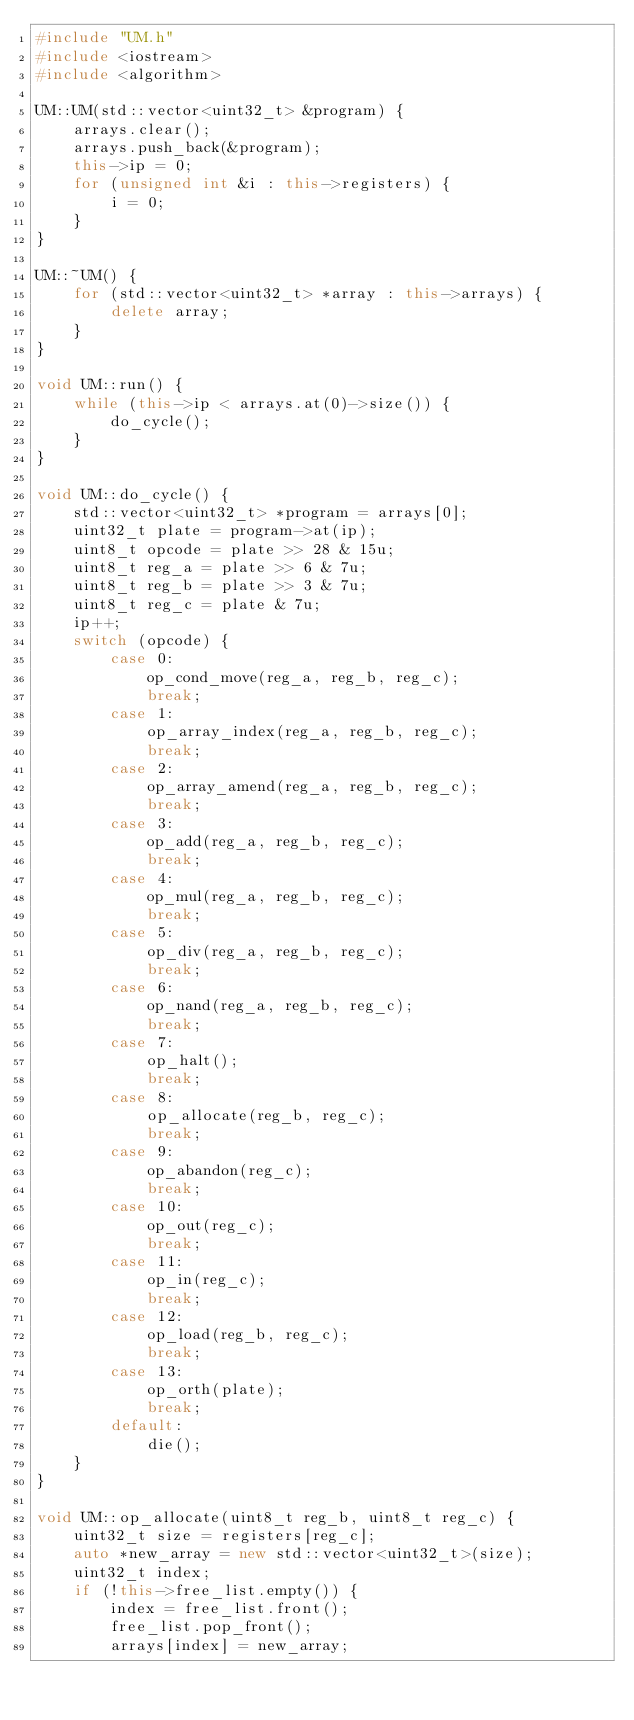Convert code to text. <code><loc_0><loc_0><loc_500><loc_500><_C++_>#include "UM.h"
#include <iostream>
#include <algorithm>

UM::UM(std::vector<uint32_t> &program) {
    arrays.clear();
    arrays.push_back(&program);
    this->ip = 0;
    for (unsigned int &i : this->registers) {
        i = 0;
    }
}

UM::~UM() {
    for (std::vector<uint32_t> *array : this->arrays) {
        delete array;
    }
}

void UM::run() {
    while (this->ip < arrays.at(0)->size()) {
        do_cycle();
    }
}

void UM::do_cycle() {
    std::vector<uint32_t> *program = arrays[0];
    uint32_t plate = program->at(ip);
    uint8_t opcode = plate >> 28 & 15u;
    uint8_t reg_a = plate >> 6 & 7u;
    uint8_t reg_b = plate >> 3 & 7u;
    uint8_t reg_c = plate & 7u;
    ip++;
    switch (opcode) {
        case 0:
            op_cond_move(reg_a, reg_b, reg_c);
            break;
        case 1:
            op_array_index(reg_a, reg_b, reg_c);
            break;
        case 2:
            op_array_amend(reg_a, reg_b, reg_c);
            break;
        case 3:
            op_add(reg_a, reg_b, reg_c);
            break;
        case 4:
            op_mul(reg_a, reg_b, reg_c);
            break;
        case 5:
            op_div(reg_a, reg_b, reg_c);
            break;
        case 6:
            op_nand(reg_a, reg_b, reg_c);
            break;
        case 7:
            op_halt();
            break;
        case 8:
            op_allocate(reg_b, reg_c);
            break;
        case 9:
            op_abandon(reg_c);
            break;
        case 10:
            op_out(reg_c);
            break;
        case 11:
            op_in(reg_c);
            break;
        case 12:
            op_load(reg_b, reg_c);
            break;
        case 13:
            op_orth(plate);
            break;
        default:
            die();
    }
}

void UM::op_allocate(uint8_t reg_b, uint8_t reg_c) {
    uint32_t size = registers[reg_c];
    auto *new_array = new std::vector<uint32_t>(size);
    uint32_t index;
    if (!this->free_list.empty()) {
        index = free_list.front();
        free_list.pop_front();
        arrays[index] = new_array;</code> 